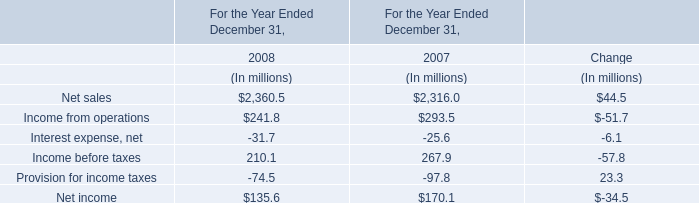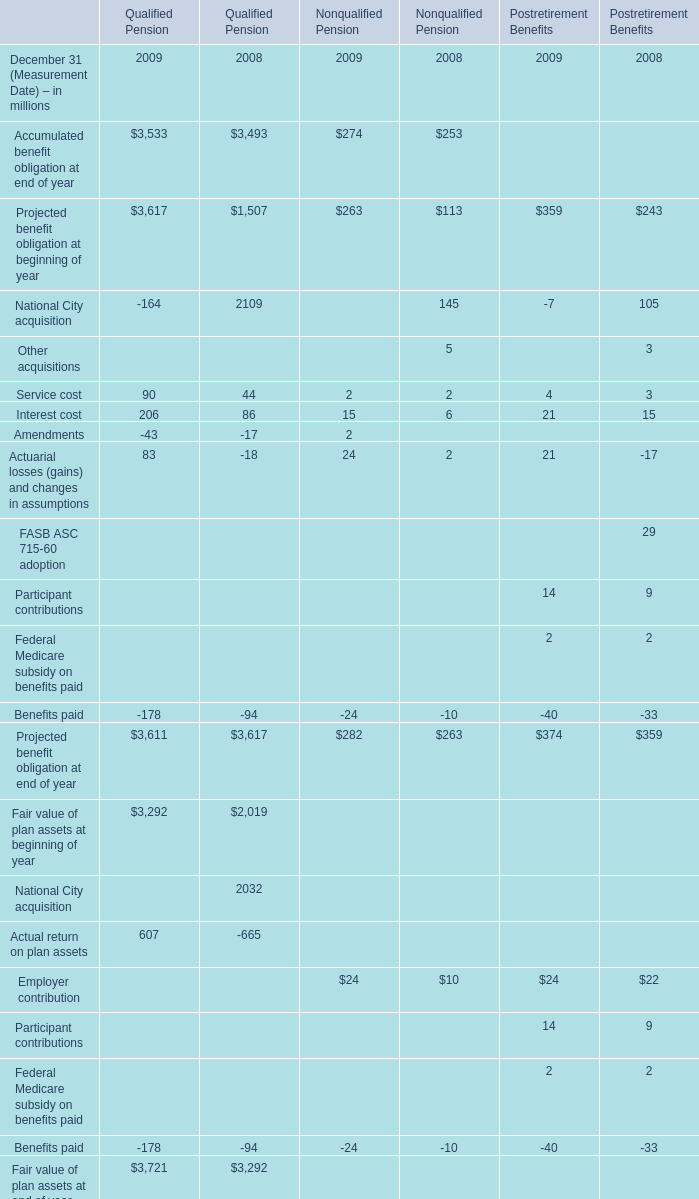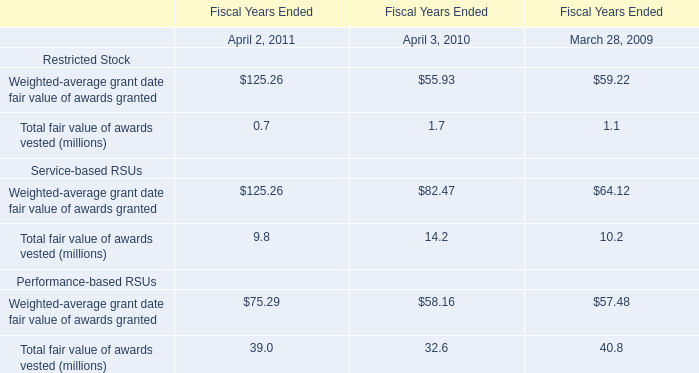Which year is Accumulated benefit obligation at end of year for Qualified Pension the most? 
Answer: 2009. 